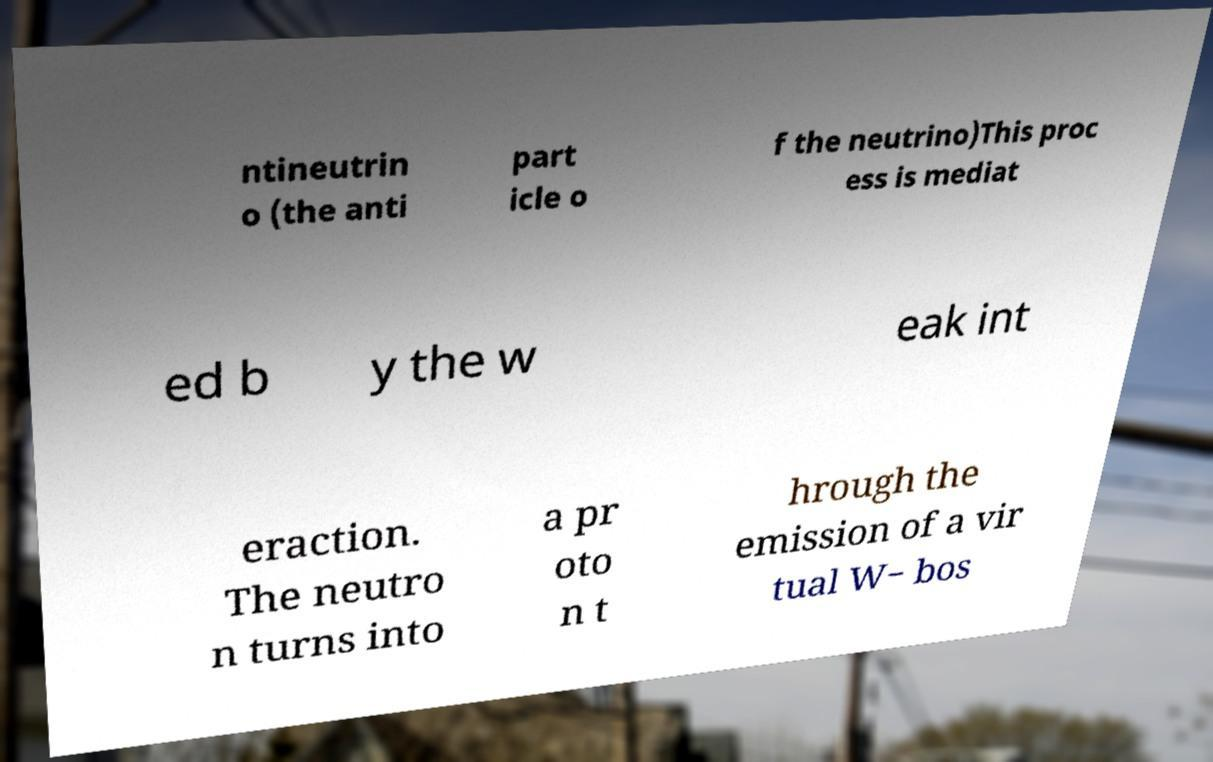I need the written content from this picture converted into text. Can you do that? ntineutrin o (the anti part icle o f the neutrino)This proc ess is mediat ed b y the w eak int eraction. The neutro n turns into a pr oto n t hrough the emission of a vir tual W− bos 